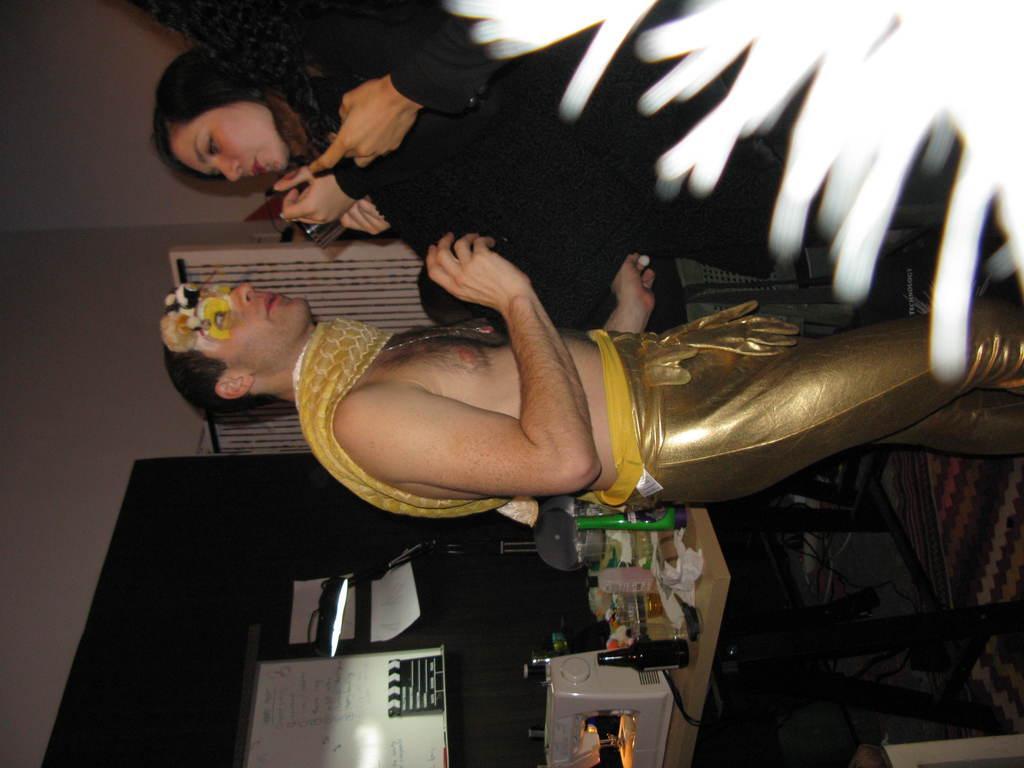In one or two sentences, can you explain what this image depicts? This is the picture of a room. In this image there are two persons standing. There is a device and there are bottles and utensils on the table. At the back there is a board on the wall and there is a text on the board and at the back there is a door. At the bottom there is a mat and there are wires. 